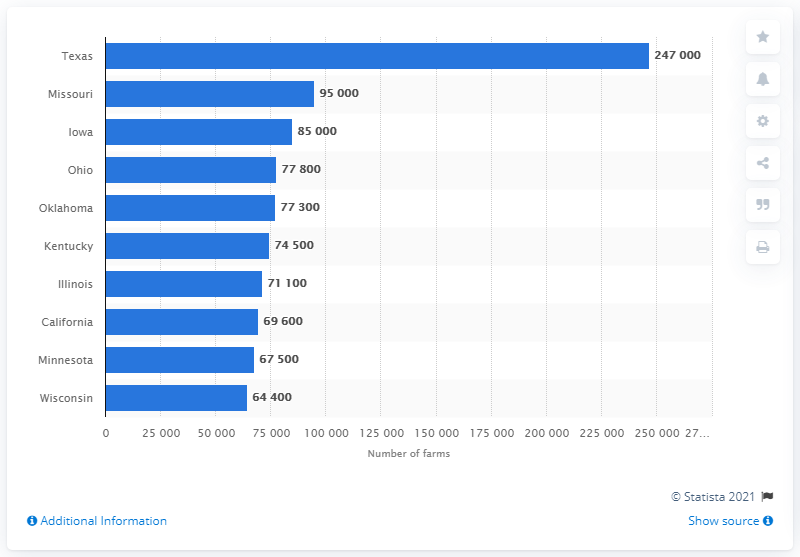Point out several critical features in this image. According to the ranking of the top ten states, Missouri was second in line. By the end of 2020, Texas had 247,000 farms. 